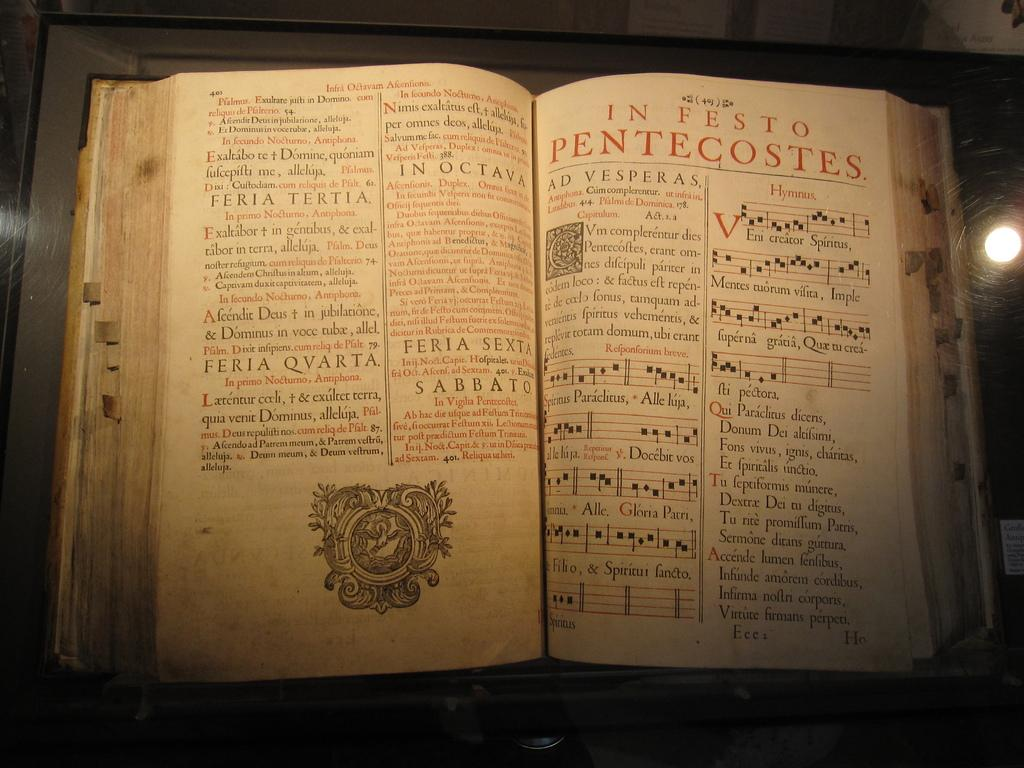<image>
Offer a succinct explanation of the picture presented. Open book on a page with red letters that says "In Festo Pentecostes". 